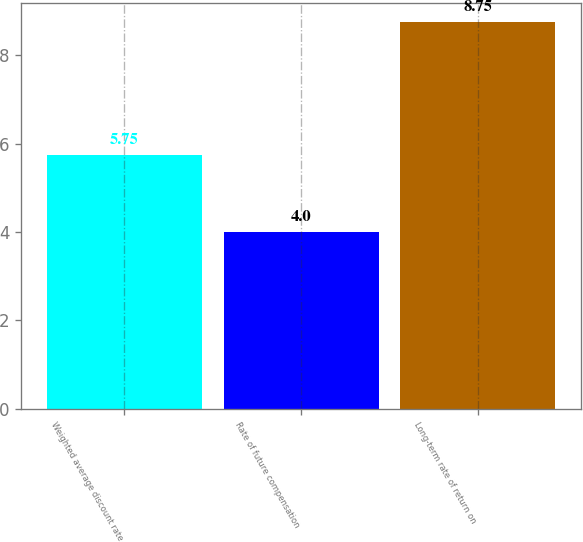Convert chart to OTSL. <chart><loc_0><loc_0><loc_500><loc_500><bar_chart><fcel>Weighted average discount rate<fcel>Rate of future compensation<fcel>Long-term rate of return on<nl><fcel>5.75<fcel>4<fcel>8.75<nl></chart> 